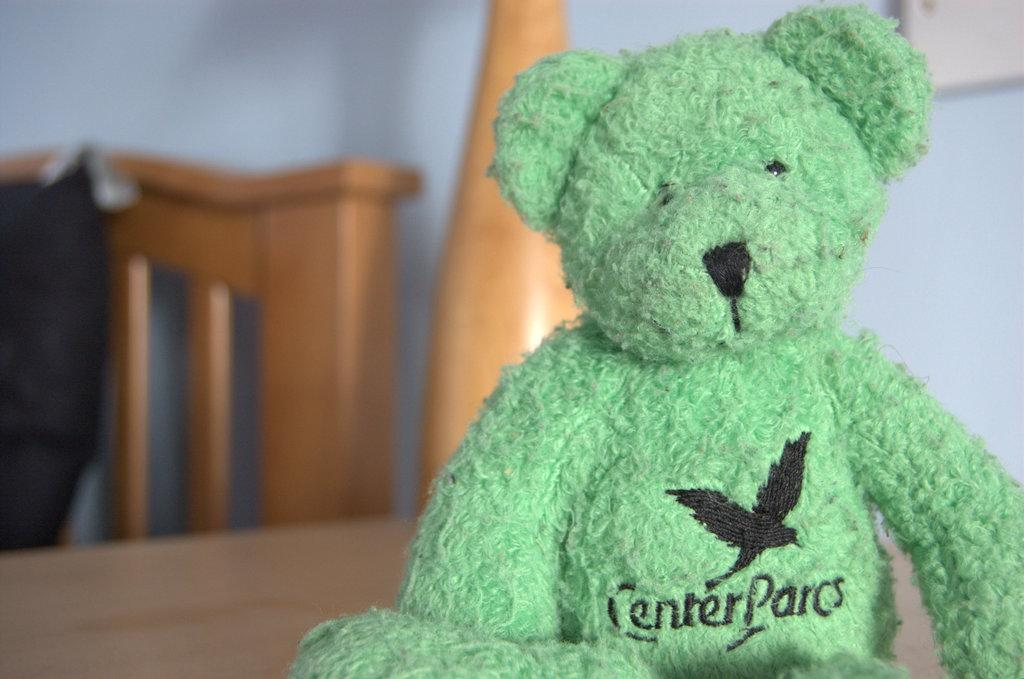What is the main object on the surface in the image? There is a teddy on the surface in the image. What can be seen behind the teddy? There appears to be a chair behind the teddy. What other objects are visible in the image? There are some objects visible in the image. What is visible in the background of the image? There is a wall in the background of the image. Can you see any mountains in the background of the image? There are no mountains visible in the background of the image; it features a wall instead. 